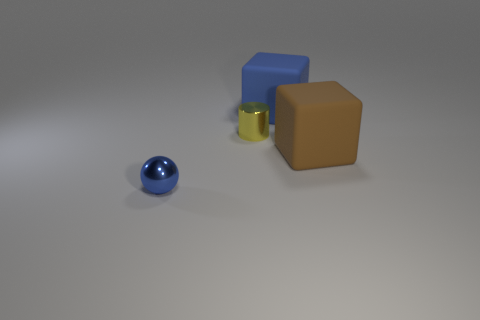There is a brown matte object; does it have the same shape as the blue object on the left side of the large blue cube?
Your answer should be compact. No. There is a blue thing right of the blue metal sphere; is its size the same as the blue sphere?
Ensure brevity in your answer.  No. There is a matte thing that is the same size as the blue matte block; what is its shape?
Offer a very short reply. Cube. Is the large brown matte object the same shape as the large blue thing?
Provide a short and direct response. Yes. What number of other objects have the same shape as the big blue object?
Give a very brief answer. 1. There is a big brown matte block; what number of big brown matte cubes are on the right side of it?
Provide a succinct answer. 0. There is a large rubber cube behind the cylinder; does it have the same color as the tiny shiny ball?
Provide a succinct answer. Yes. How many brown things have the same size as the cylinder?
Provide a short and direct response. 0. What shape is the yellow thing that is the same material as the small blue sphere?
Your answer should be very brief. Cylinder. Are there any tiny shiny objects of the same color as the tiny cylinder?
Ensure brevity in your answer.  No. 